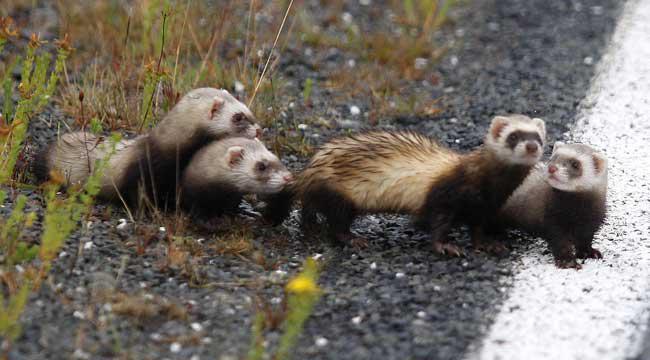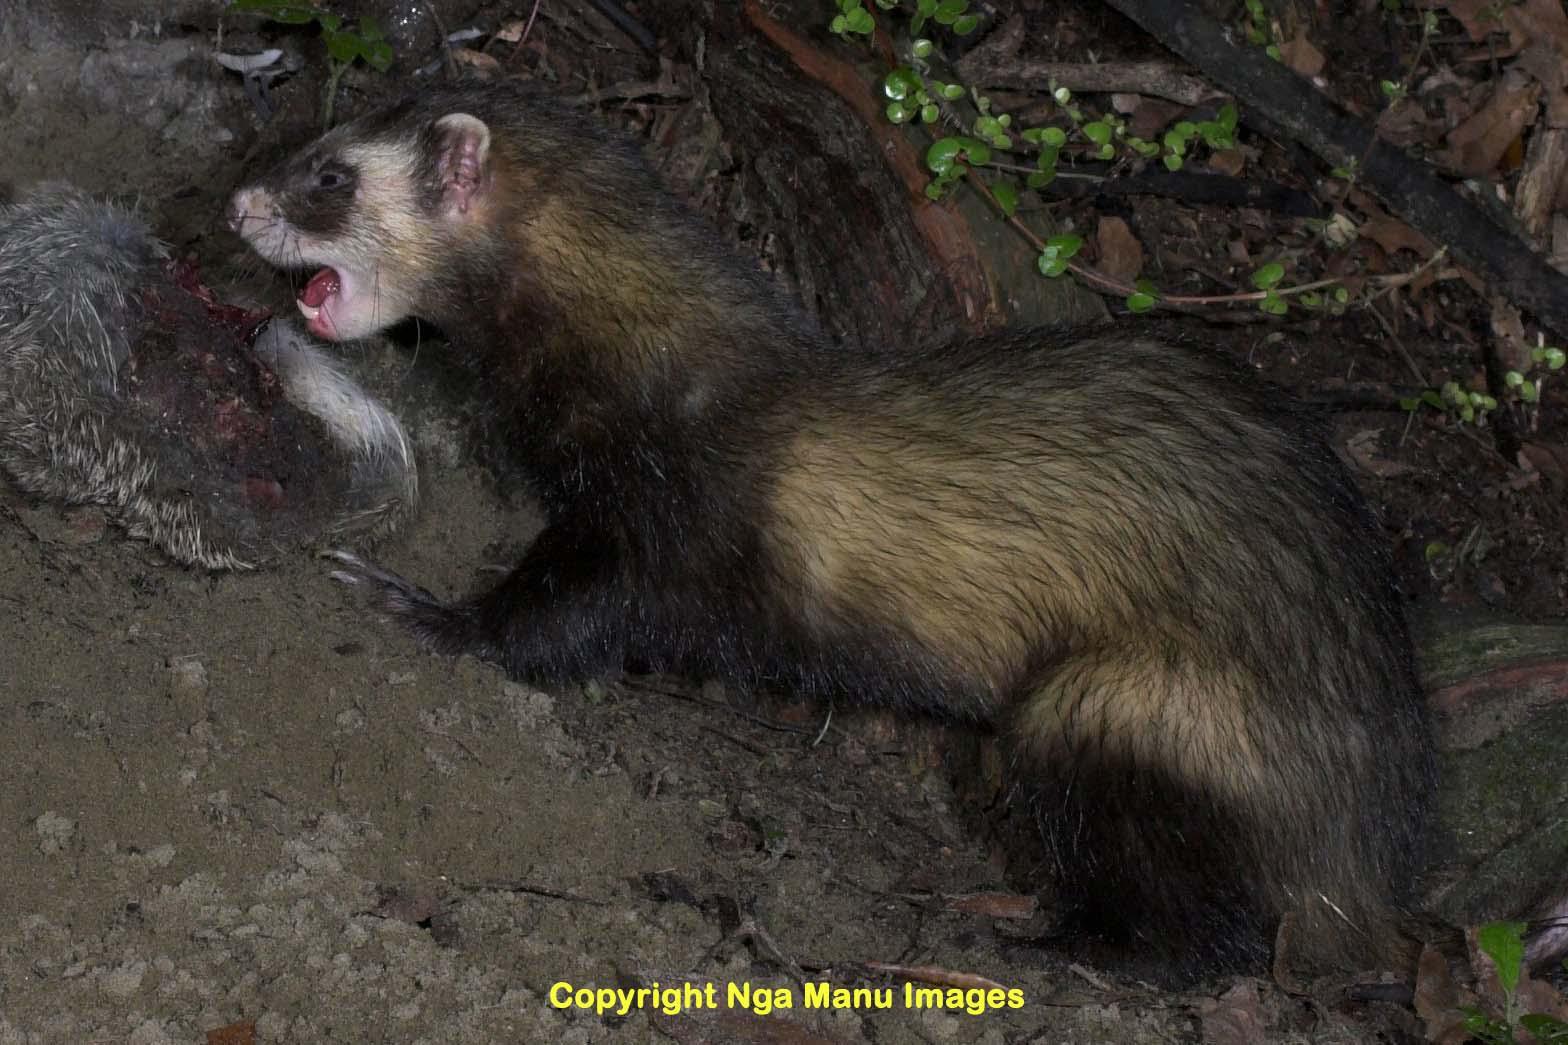The first image is the image on the left, the second image is the image on the right. For the images shown, is this caption "An image shows a row of exactly three ferret-like animals of different sizes." true? Answer yes or no. No. 